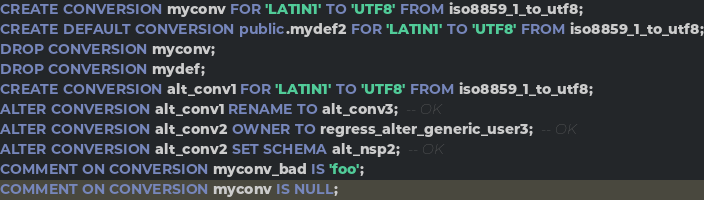<code> <loc_0><loc_0><loc_500><loc_500><_SQL_>CREATE CONVERSION myconv FOR 'LATIN1' TO 'UTF8' FROM iso8859_1_to_utf8;
CREATE DEFAULT CONVERSION public.mydef2 FOR 'LATIN1' TO 'UTF8' FROM iso8859_1_to_utf8;
DROP CONVERSION myconv;
DROP CONVERSION mydef;
CREATE CONVERSION alt_conv1 FOR 'LATIN1' TO 'UTF8' FROM iso8859_1_to_utf8;
ALTER CONVERSION alt_conv1 RENAME TO alt_conv3;  -- OK
ALTER CONVERSION alt_conv2 OWNER TO regress_alter_generic_user3;  -- OK
ALTER CONVERSION alt_conv2 SET SCHEMA alt_nsp2;  -- OK
COMMENT ON CONVERSION myconv_bad IS 'foo';
COMMENT ON CONVERSION myconv IS NULL;</code> 